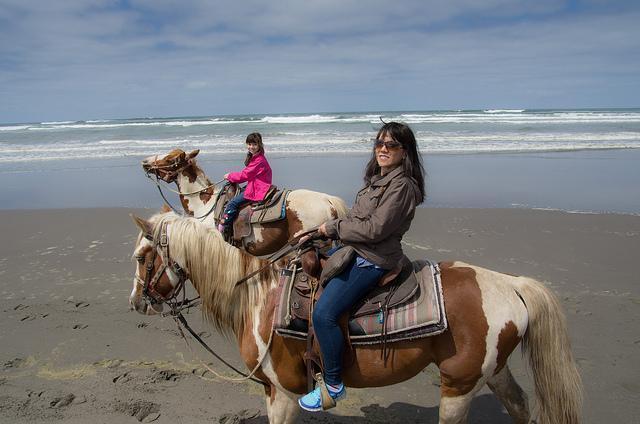How many horses are in the photo?
Give a very brief answer. 2. How many people can you see?
Give a very brief answer. 2. 